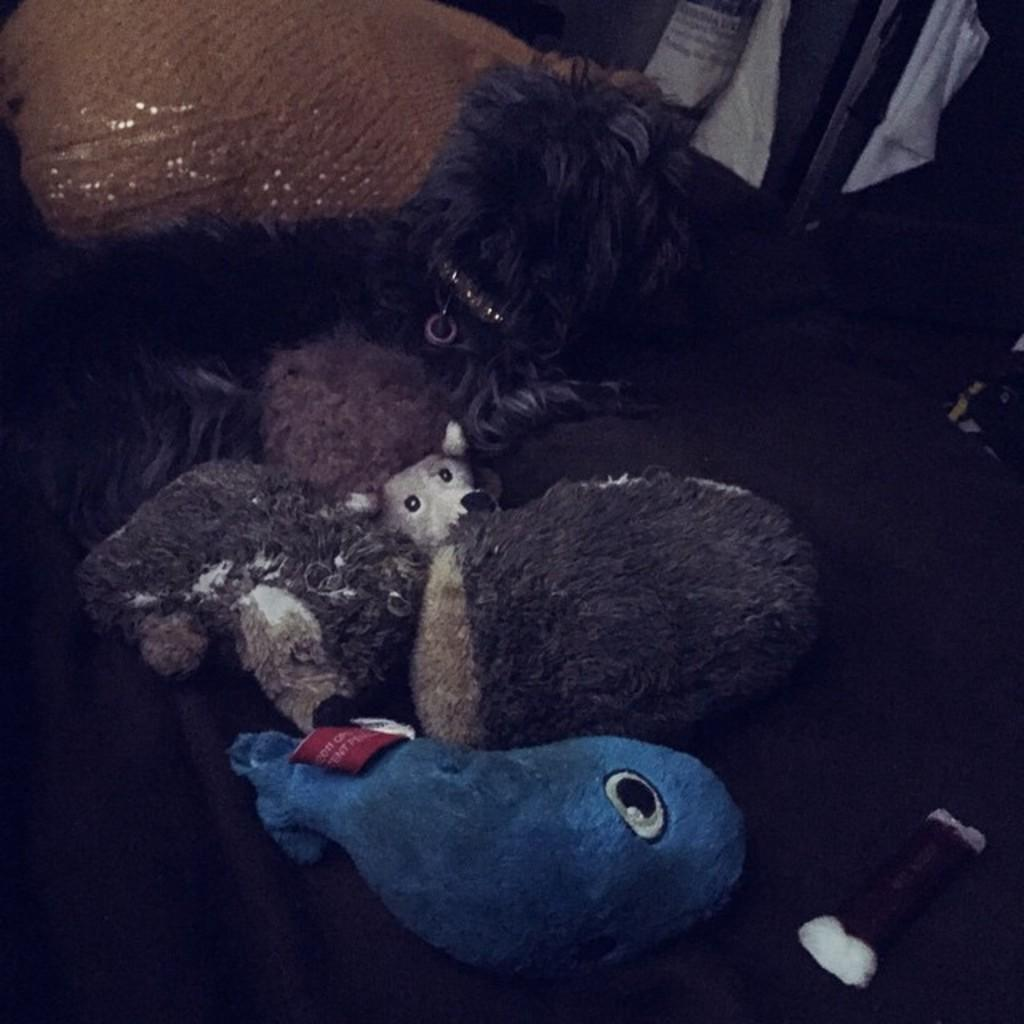What type of objects can be seen in the image? There are toys in the image. What type of rings can be seen in the image? There are no rings present in the image; it features toys. What type of meeting is taking place in the image? There is no meeting depicted in the image; it features toys. 